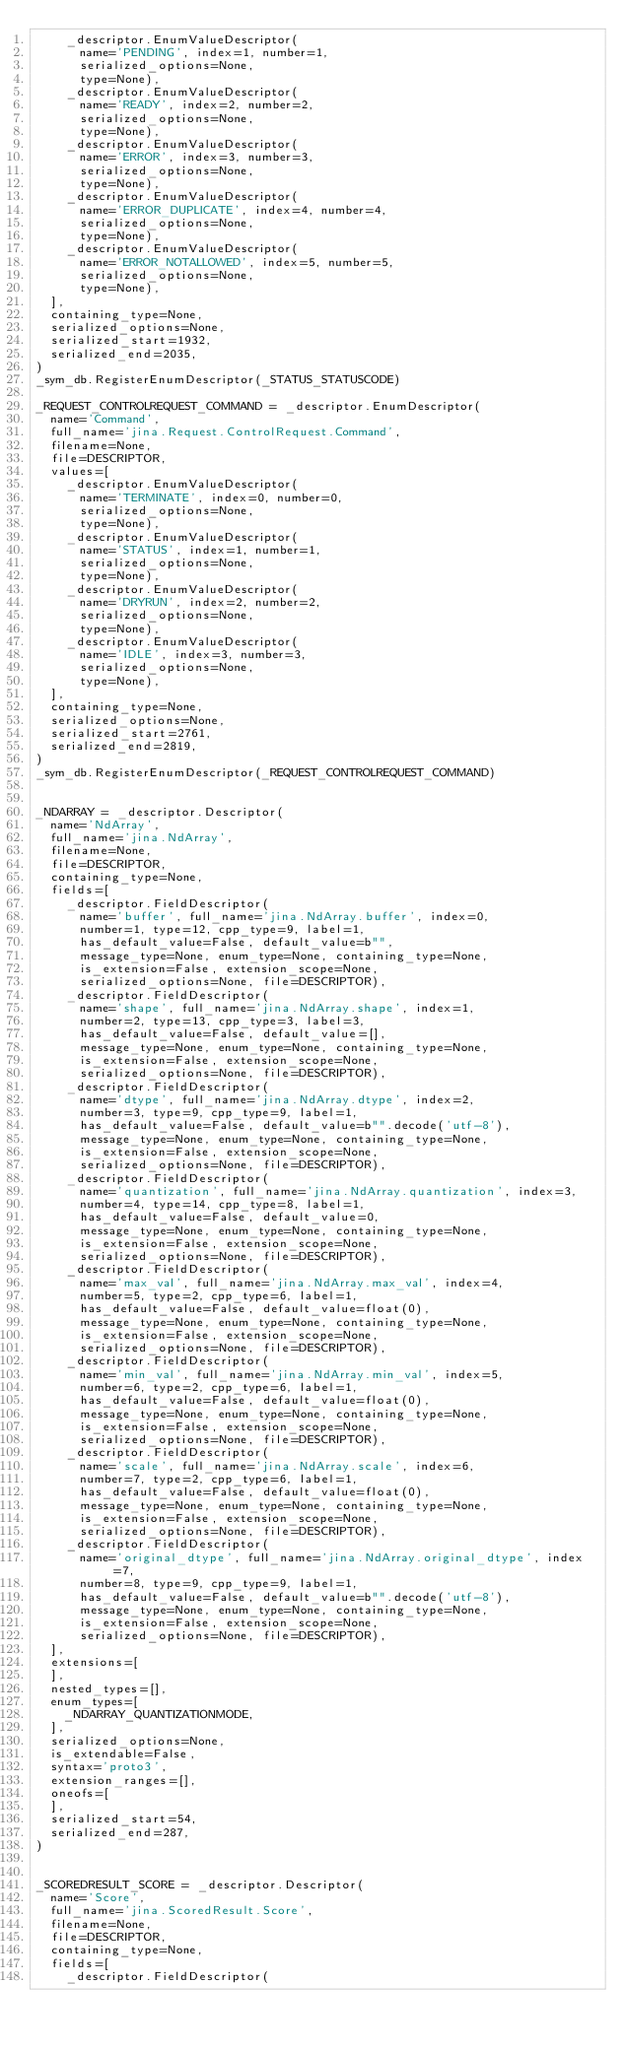<code> <loc_0><loc_0><loc_500><loc_500><_Python_>    _descriptor.EnumValueDescriptor(
      name='PENDING', index=1, number=1,
      serialized_options=None,
      type=None),
    _descriptor.EnumValueDescriptor(
      name='READY', index=2, number=2,
      serialized_options=None,
      type=None),
    _descriptor.EnumValueDescriptor(
      name='ERROR', index=3, number=3,
      serialized_options=None,
      type=None),
    _descriptor.EnumValueDescriptor(
      name='ERROR_DUPLICATE', index=4, number=4,
      serialized_options=None,
      type=None),
    _descriptor.EnumValueDescriptor(
      name='ERROR_NOTALLOWED', index=5, number=5,
      serialized_options=None,
      type=None),
  ],
  containing_type=None,
  serialized_options=None,
  serialized_start=1932,
  serialized_end=2035,
)
_sym_db.RegisterEnumDescriptor(_STATUS_STATUSCODE)

_REQUEST_CONTROLREQUEST_COMMAND = _descriptor.EnumDescriptor(
  name='Command',
  full_name='jina.Request.ControlRequest.Command',
  filename=None,
  file=DESCRIPTOR,
  values=[
    _descriptor.EnumValueDescriptor(
      name='TERMINATE', index=0, number=0,
      serialized_options=None,
      type=None),
    _descriptor.EnumValueDescriptor(
      name='STATUS', index=1, number=1,
      serialized_options=None,
      type=None),
    _descriptor.EnumValueDescriptor(
      name='DRYRUN', index=2, number=2,
      serialized_options=None,
      type=None),
    _descriptor.EnumValueDescriptor(
      name='IDLE', index=3, number=3,
      serialized_options=None,
      type=None),
  ],
  containing_type=None,
  serialized_options=None,
  serialized_start=2761,
  serialized_end=2819,
)
_sym_db.RegisterEnumDescriptor(_REQUEST_CONTROLREQUEST_COMMAND)


_NDARRAY = _descriptor.Descriptor(
  name='NdArray',
  full_name='jina.NdArray',
  filename=None,
  file=DESCRIPTOR,
  containing_type=None,
  fields=[
    _descriptor.FieldDescriptor(
      name='buffer', full_name='jina.NdArray.buffer', index=0,
      number=1, type=12, cpp_type=9, label=1,
      has_default_value=False, default_value=b"",
      message_type=None, enum_type=None, containing_type=None,
      is_extension=False, extension_scope=None,
      serialized_options=None, file=DESCRIPTOR),
    _descriptor.FieldDescriptor(
      name='shape', full_name='jina.NdArray.shape', index=1,
      number=2, type=13, cpp_type=3, label=3,
      has_default_value=False, default_value=[],
      message_type=None, enum_type=None, containing_type=None,
      is_extension=False, extension_scope=None,
      serialized_options=None, file=DESCRIPTOR),
    _descriptor.FieldDescriptor(
      name='dtype', full_name='jina.NdArray.dtype', index=2,
      number=3, type=9, cpp_type=9, label=1,
      has_default_value=False, default_value=b"".decode('utf-8'),
      message_type=None, enum_type=None, containing_type=None,
      is_extension=False, extension_scope=None,
      serialized_options=None, file=DESCRIPTOR),
    _descriptor.FieldDescriptor(
      name='quantization', full_name='jina.NdArray.quantization', index=3,
      number=4, type=14, cpp_type=8, label=1,
      has_default_value=False, default_value=0,
      message_type=None, enum_type=None, containing_type=None,
      is_extension=False, extension_scope=None,
      serialized_options=None, file=DESCRIPTOR),
    _descriptor.FieldDescriptor(
      name='max_val', full_name='jina.NdArray.max_val', index=4,
      number=5, type=2, cpp_type=6, label=1,
      has_default_value=False, default_value=float(0),
      message_type=None, enum_type=None, containing_type=None,
      is_extension=False, extension_scope=None,
      serialized_options=None, file=DESCRIPTOR),
    _descriptor.FieldDescriptor(
      name='min_val', full_name='jina.NdArray.min_val', index=5,
      number=6, type=2, cpp_type=6, label=1,
      has_default_value=False, default_value=float(0),
      message_type=None, enum_type=None, containing_type=None,
      is_extension=False, extension_scope=None,
      serialized_options=None, file=DESCRIPTOR),
    _descriptor.FieldDescriptor(
      name='scale', full_name='jina.NdArray.scale', index=6,
      number=7, type=2, cpp_type=6, label=1,
      has_default_value=False, default_value=float(0),
      message_type=None, enum_type=None, containing_type=None,
      is_extension=False, extension_scope=None,
      serialized_options=None, file=DESCRIPTOR),
    _descriptor.FieldDescriptor(
      name='original_dtype', full_name='jina.NdArray.original_dtype', index=7,
      number=8, type=9, cpp_type=9, label=1,
      has_default_value=False, default_value=b"".decode('utf-8'),
      message_type=None, enum_type=None, containing_type=None,
      is_extension=False, extension_scope=None,
      serialized_options=None, file=DESCRIPTOR),
  ],
  extensions=[
  ],
  nested_types=[],
  enum_types=[
    _NDARRAY_QUANTIZATIONMODE,
  ],
  serialized_options=None,
  is_extendable=False,
  syntax='proto3',
  extension_ranges=[],
  oneofs=[
  ],
  serialized_start=54,
  serialized_end=287,
)


_SCOREDRESULT_SCORE = _descriptor.Descriptor(
  name='Score',
  full_name='jina.ScoredResult.Score',
  filename=None,
  file=DESCRIPTOR,
  containing_type=None,
  fields=[
    _descriptor.FieldDescriptor(</code> 